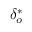<formula> <loc_0><loc_0><loc_500><loc_500>{ \delta } _ { o } ^ { * }</formula> 